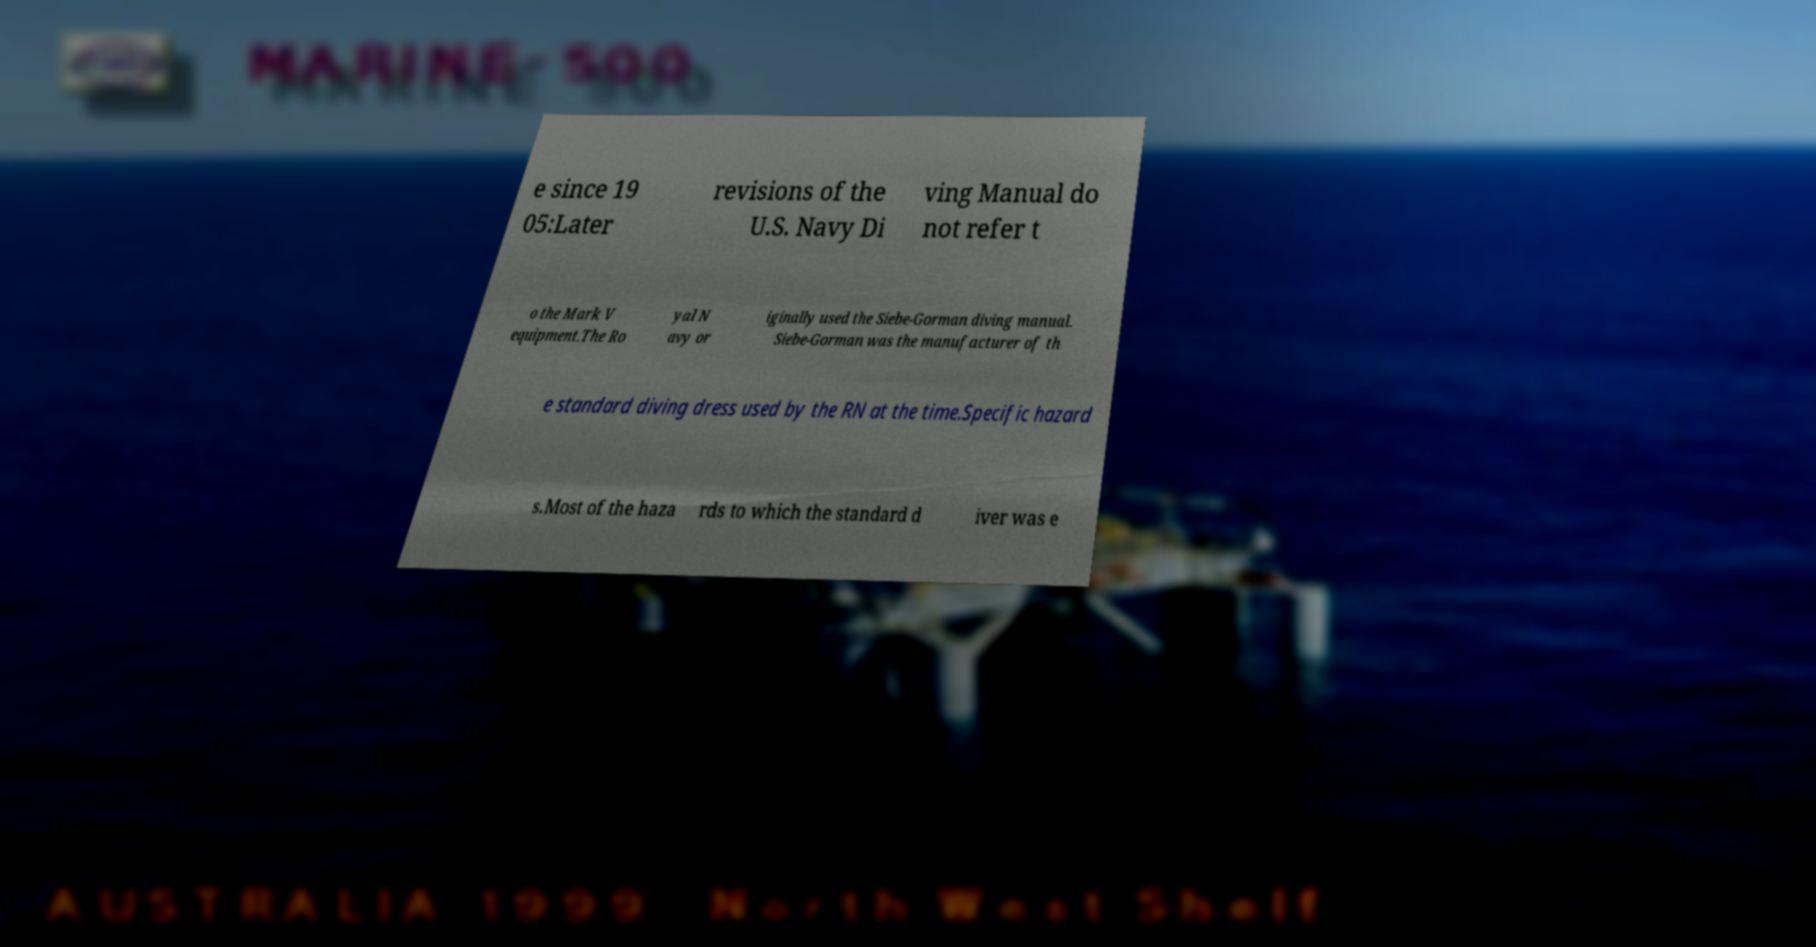For documentation purposes, I need the text within this image transcribed. Could you provide that? e since 19 05:Later revisions of the U.S. Navy Di ving Manual do not refer t o the Mark V equipment.The Ro yal N avy or iginally used the Siebe-Gorman diving manual. Siebe-Gorman was the manufacturer of th e standard diving dress used by the RN at the time.Specific hazard s.Most of the haza rds to which the standard d iver was e 